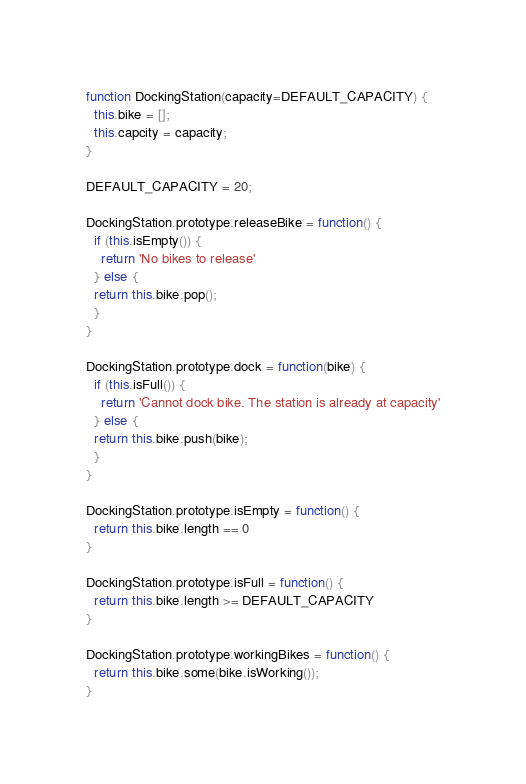Convert code to text. <code><loc_0><loc_0><loc_500><loc_500><_JavaScript_>function DockingStation(capacity=DEFAULT_CAPACITY) {
  this.bike = [];
  this.capcity = capacity;
}

DEFAULT_CAPACITY = 20;

DockingStation.prototype.releaseBike = function() {
  if (this.isEmpty()) {
    return 'No bikes to release'
  } else {
  return this.bike.pop();
  }
}

DockingStation.prototype.dock = function(bike) {
  if (this.isFull()) {
    return 'Cannot dock bike. The station is already at capacity'
  } else {
  return this.bike.push(bike);
  }
}

DockingStation.prototype.isEmpty = function() {
  return this.bike.length == 0
}

DockingStation.prototype.isFull = function() {
  return this.bike.length >= DEFAULT_CAPACITY
}

DockingStation.prototype.workingBikes = function() {
  return this.bike.some(bike.isWorking());
}
</code> 